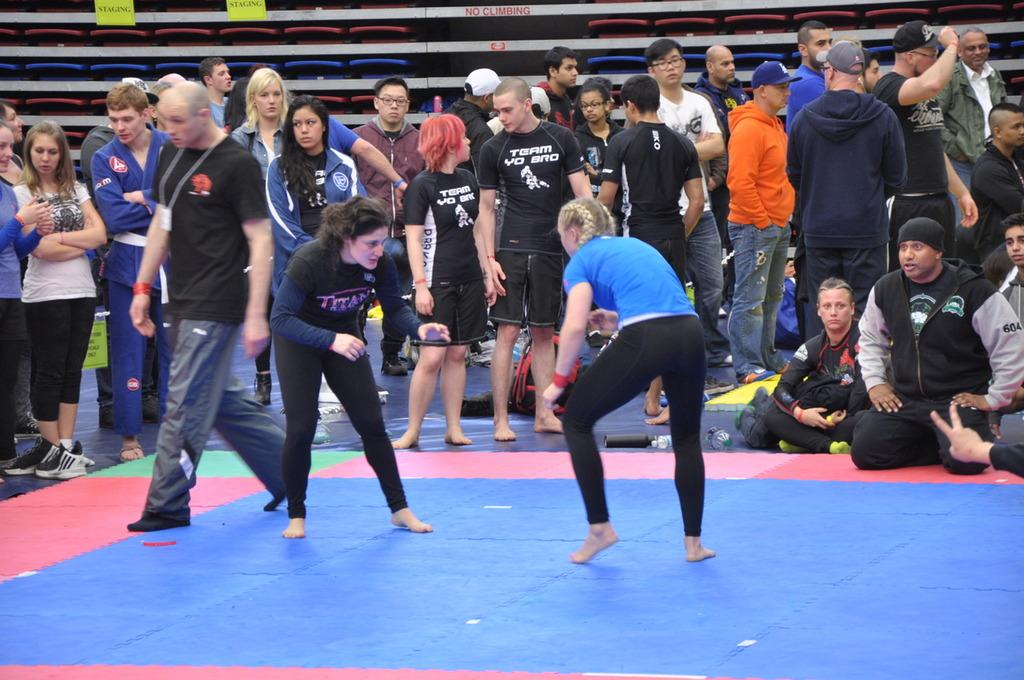How many people are in the image? There are many persons in the image. What are some of the positions the persons are in? Some of the persons are standing on the ground, while others are sitting on the ground. How many toads are visible in the image? There are no toads present in the image. What type of writer can be seen working on their manuscript in the image? There is no writer present in the image. 